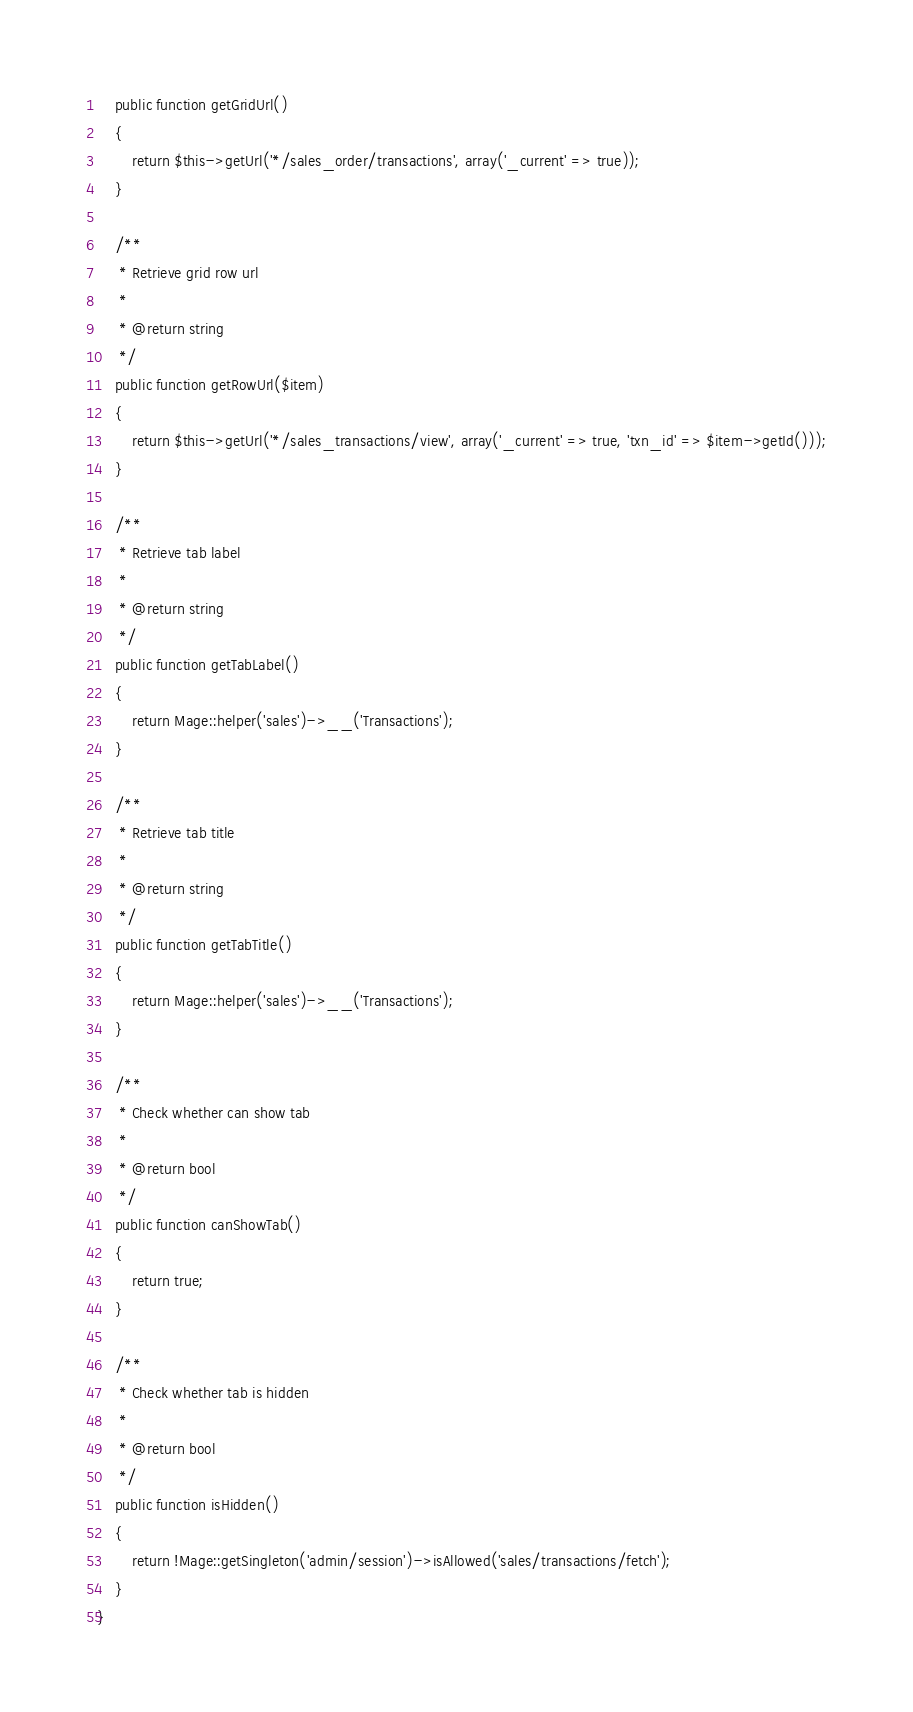Convert code to text. <code><loc_0><loc_0><loc_500><loc_500><_PHP_>    public function getGridUrl()
    {
        return $this->getUrl('*/sales_order/transactions', array('_current' => true));
    }

    /**
     * Retrieve grid row url
     *
     * @return string
     */
    public function getRowUrl($item)
    {
        return $this->getUrl('*/sales_transactions/view', array('_current' => true, 'txn_id' => $item->getId()));
    }

    /**
     * Retrieve tab label
     *
     * @return string
     */
    public function getTabLabel()
    {
        return Mage::helper('sales')->__('Transactions');
    }

    /**
     * Retrieve tab title
     *
     * @return string
     */
    public function getTabTitle()
    {
        return Mage::helper('sales')->__('Transactions');
    }

    /**
     * Check whether can show tab
     *
     * @return bool
     */
    public function canShowTab()
    {
        return true;
    }

    /**
     * Check whether tab is hidden
     *
     * @return bool
     */
    public function isHidden()
    {
        return !Mage::getSingleton('admin/session')->isAllowed('sales/transactions/fetch');
    }
}
</code> 